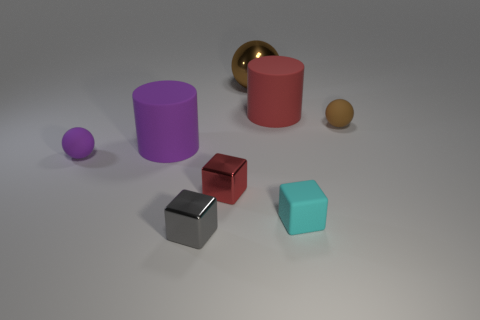What is the shape of the large rubber thing behind the big rubber thing to the left of the big brown metal ball? cylinder 